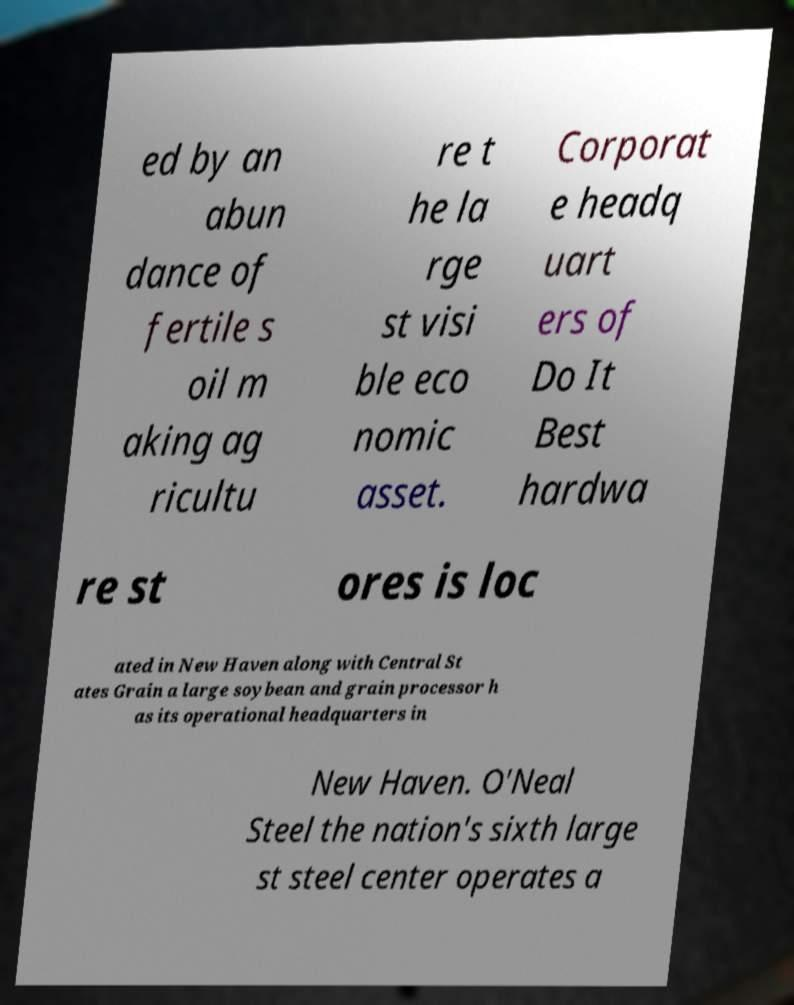Could you extract and type out the text from this image? ed by an abun dance of fertile s oil m aking ag ricultu re t he la rge st visi ble eco nomic asset. Corporat e headq uart ers of Do It Best hardwa re st ores is loc ated in New Haven along with Central St ates Grain a large soybean and grain processor h as its operational headquarters in New Haven. O'Neal Steel the nation's sixth large st steel center operates a 